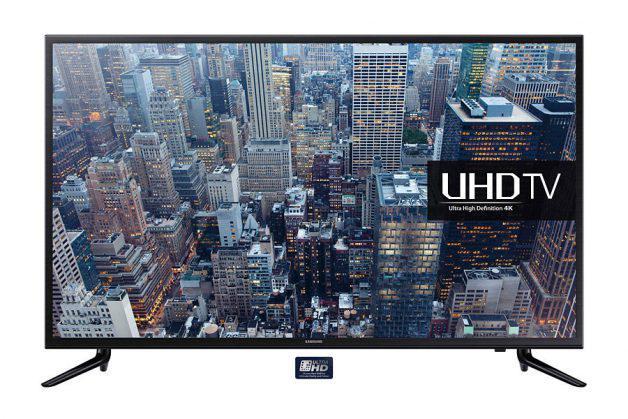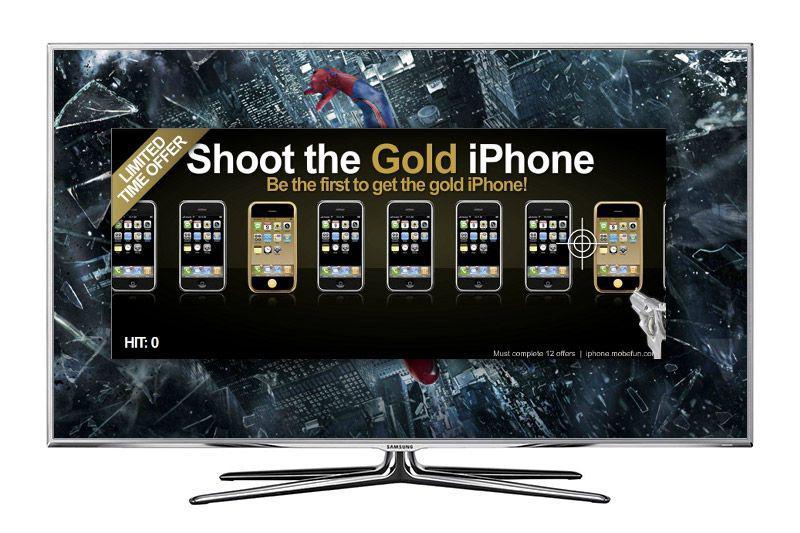The first image is the image on the left, the second image is the image on the right. Examine the images to the left and right. Is the description "Each image shows a single flat screen TV, and at least one image features an aerial city view on the screen." accurate? Answer yes or no. Yes. 